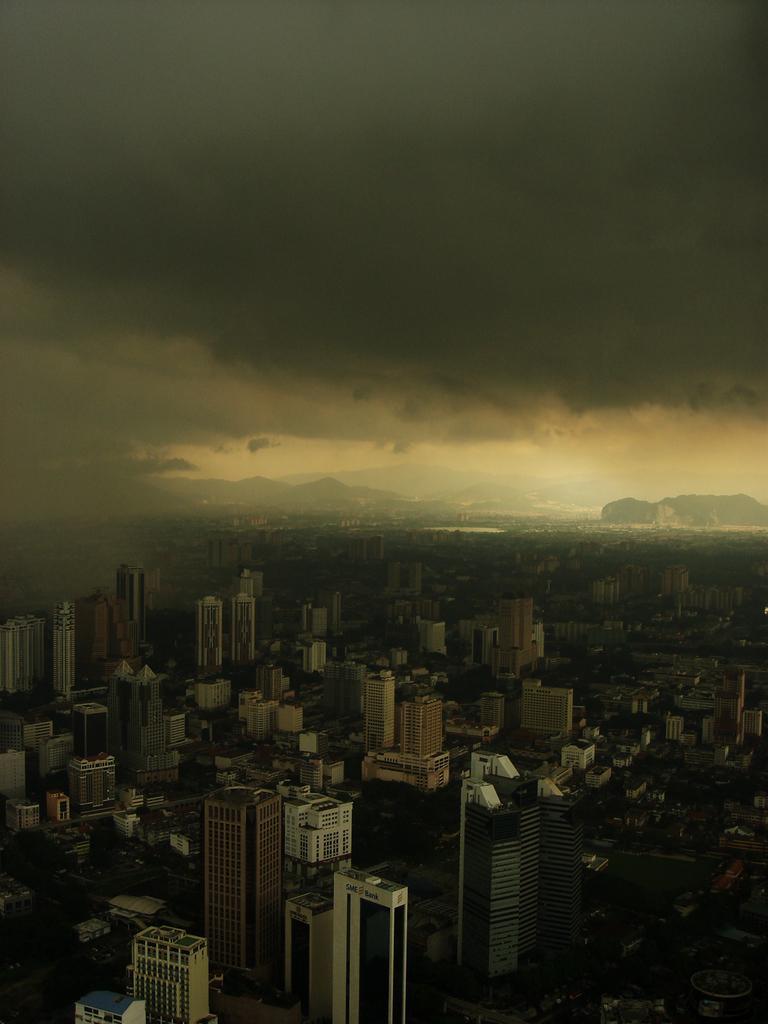Describe this image in one or two sentences. In this picture we can see buildings, trees and hills. At the top of the image, there is the cloudy sky. 